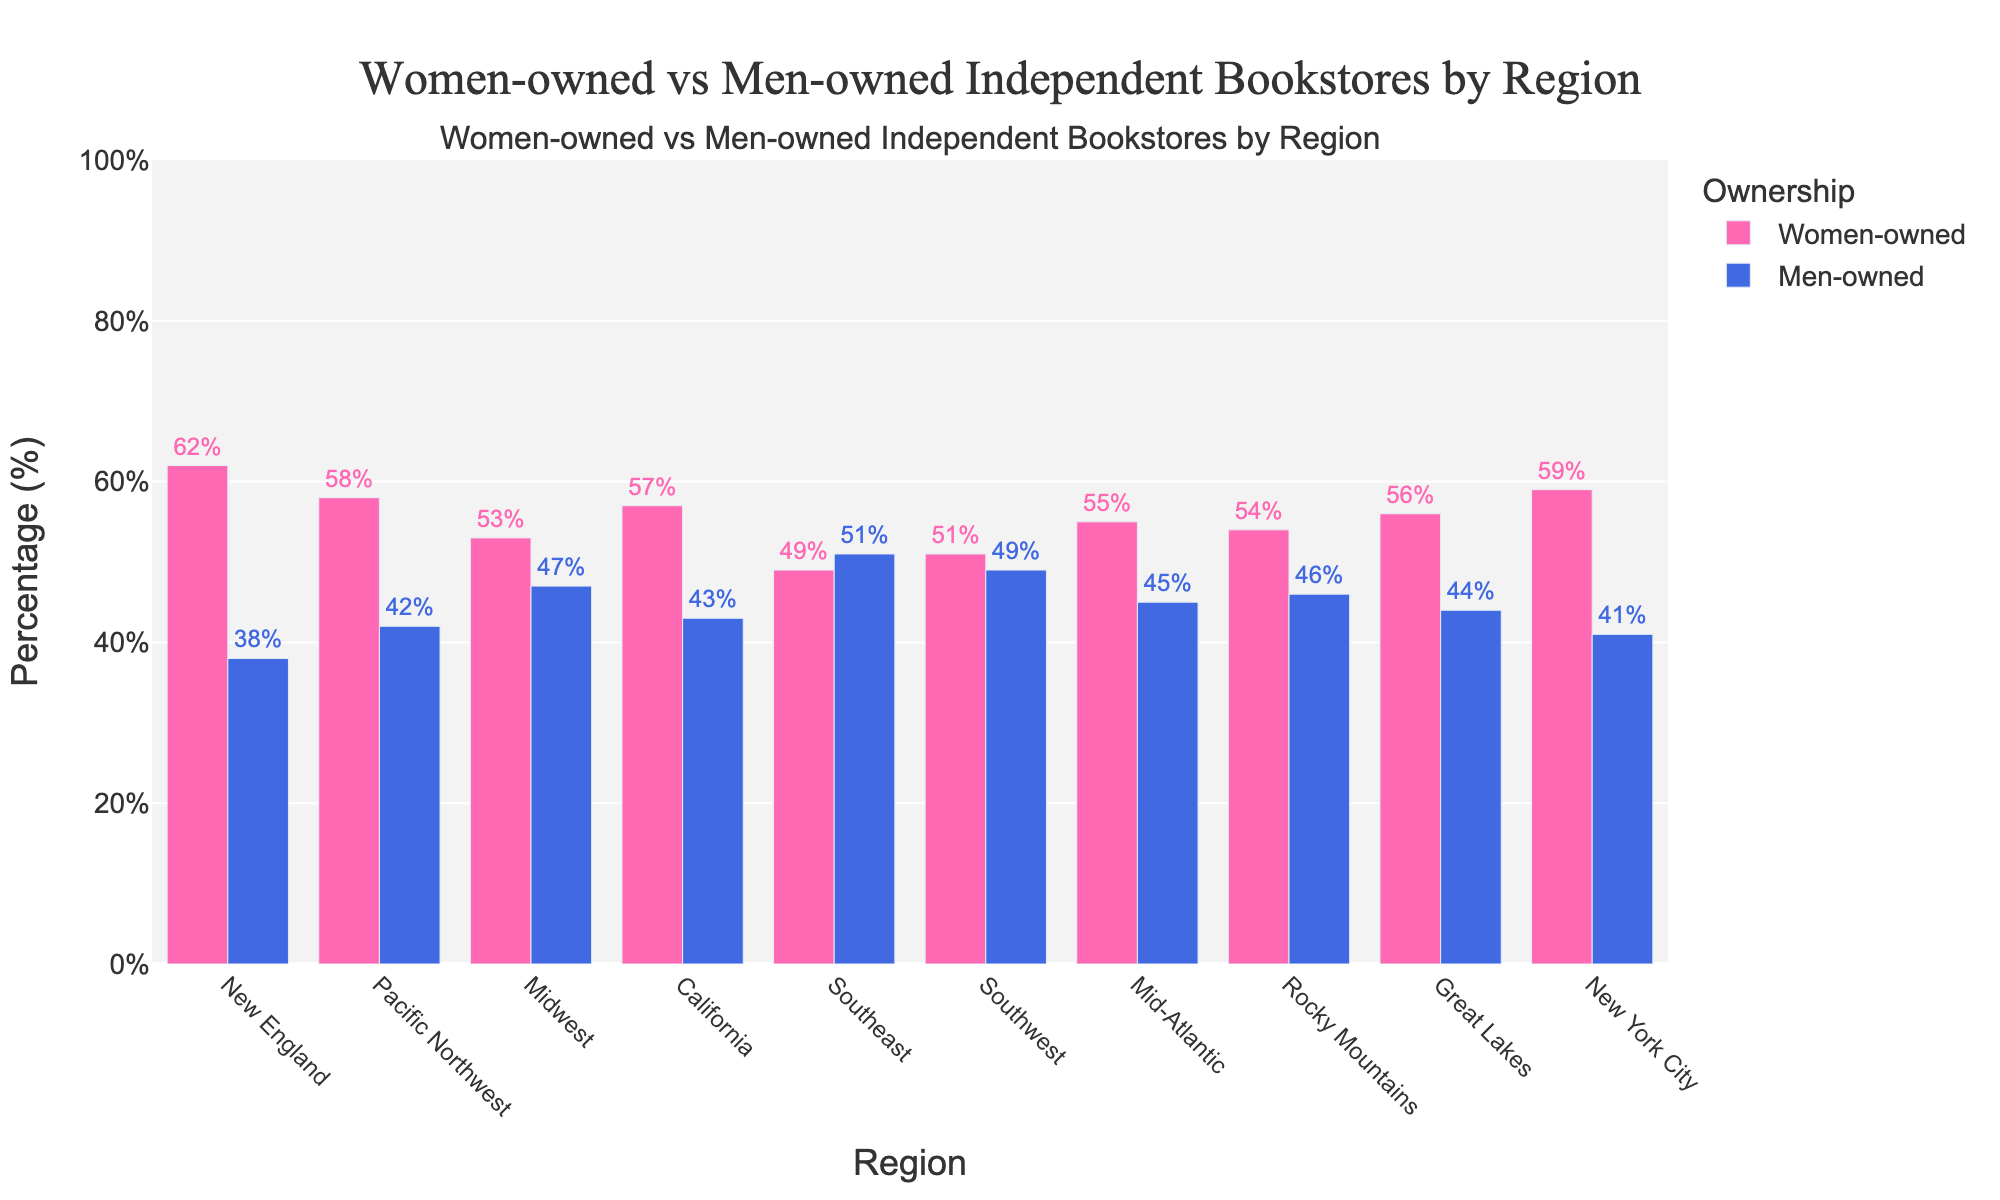What region has the highest percentage of women-owned bookstores? The tallest pink bar represents the region with the highest percentage of women-owned bookstores. This bar is in New England with 62%.
Answer: New England Which region has the most balanced ownership between women and men? The region where the bars for women-owned and men-owned bookstores are closest in height indicates balanced ownership. The Southeast has 49% women-owned and 51% men-owned, the most balanced.
Answer: Southeast Is the percentage of women-owned bookstores in New York City higher than that in California? Compare the heights of the pink bars for New York City and California, with New York City at 59% and California at 57%.
Answer: Yes What is the average percentage of women-owned bookstores in the Midwest, Southeast, and Southwest regions? Add the percentages of women-owned bookstores in the Midwest (53%), Southeast (49%), and Southwest (51%), and then divide by 3. (53 + 49 + 51) / 3 = 51%.
Answer: 51% In which region is the gap between women-owned and men-owned bookstores the largest? Look for the region where the difference between the heights of pink and blue bars is the greatest. In New England, the gap is most significant (62% - 38% = 24%).
Answer: New England What is the combined percentage of women-owned bookstores for California and the Pacific Northwest? Add the percentages of women-owned bookstores in California (57%) and the Pacific Northwest (58%). 57 + 58 = 115%.
Answer: 115% Which region has fewer men-owned bookstores, the Mid-Atlantic or the Midwest? Compare the blue bars for the Mid-Atlantic and Midwest. The Mid-Atlantic has 45%, and the Midwest has 47%.
Answer: Mid-Atlantic How much higher is the percentage of women-owned bookstores in New York City compared to the Southeast? Subtract the percentage of women-owned bookstores in the Southeast (49%) from that in New York City (59%). 59 - 49 = 10%.
Answer: 10% Which regions have women-owned bookstores exceeding 55%? Identify regions where the pink bar exceeds 55%. These regions are New England (62%), Pacific Northwest (58%), California (57%), Great Lakes (56%), and New York City (59%).
Answer: New England, Pacific Northwest, California, Great Lakes, New York City What is the total percentage of men-owned bookstores across all regions? Add the percentages of men-owned bookstores for all regions: 38 + 42 + 47 + 43 + 51 + 49 + 45 + 46 + 44 + 41 = 446%.
Answer: 446% 